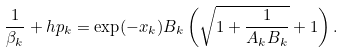<formula> <loc_0><loc_0><loc_500><loc_500>\frac { 1 } { \beta _ { k } } + h p _ { k } = \exp ( - x _ { k } ) B _ { k } \left ( \sqrt { 1 + \frac { 1 } { A _ { k } B _ { k } } } + 1 \right ) .</formula> 